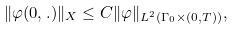<formula> <loc_0><loc_0><loc_500><loc_500>\| \varphi ( 0 , . ) \| _ { X } \leq C \| \varphi \| _ { L ^ { 2 } ( \Gamma _ { 0 } \times ( 0 , T ) ) } ,</formula> 